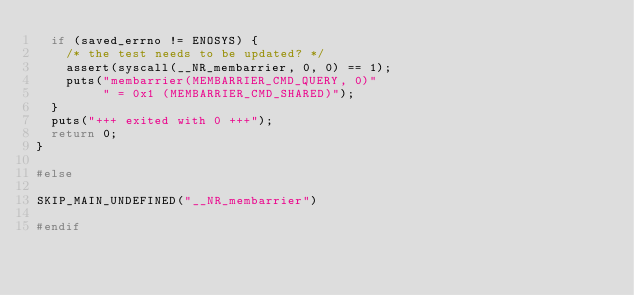<code> <loc_0><loc_0><loc_500><loc_500><_C_>	if (saved_errno != ENOSYS) {
		/* the test needs to be updated? */
		assert(syscall(__NR_membarrier, 0, 0) == 1);
		puts("membarrier(MEMBARRIER_CMD_QUERY, 0)"
		     " = 0x1 (MEMBARRIER_CMD_SHARED)");
	}
	puts("+++ exited with 0 +++");
	return 0;
}

#else

SKIP_MAIN_UNDEFINED("__NR_membarrier")

#endif
</code> 